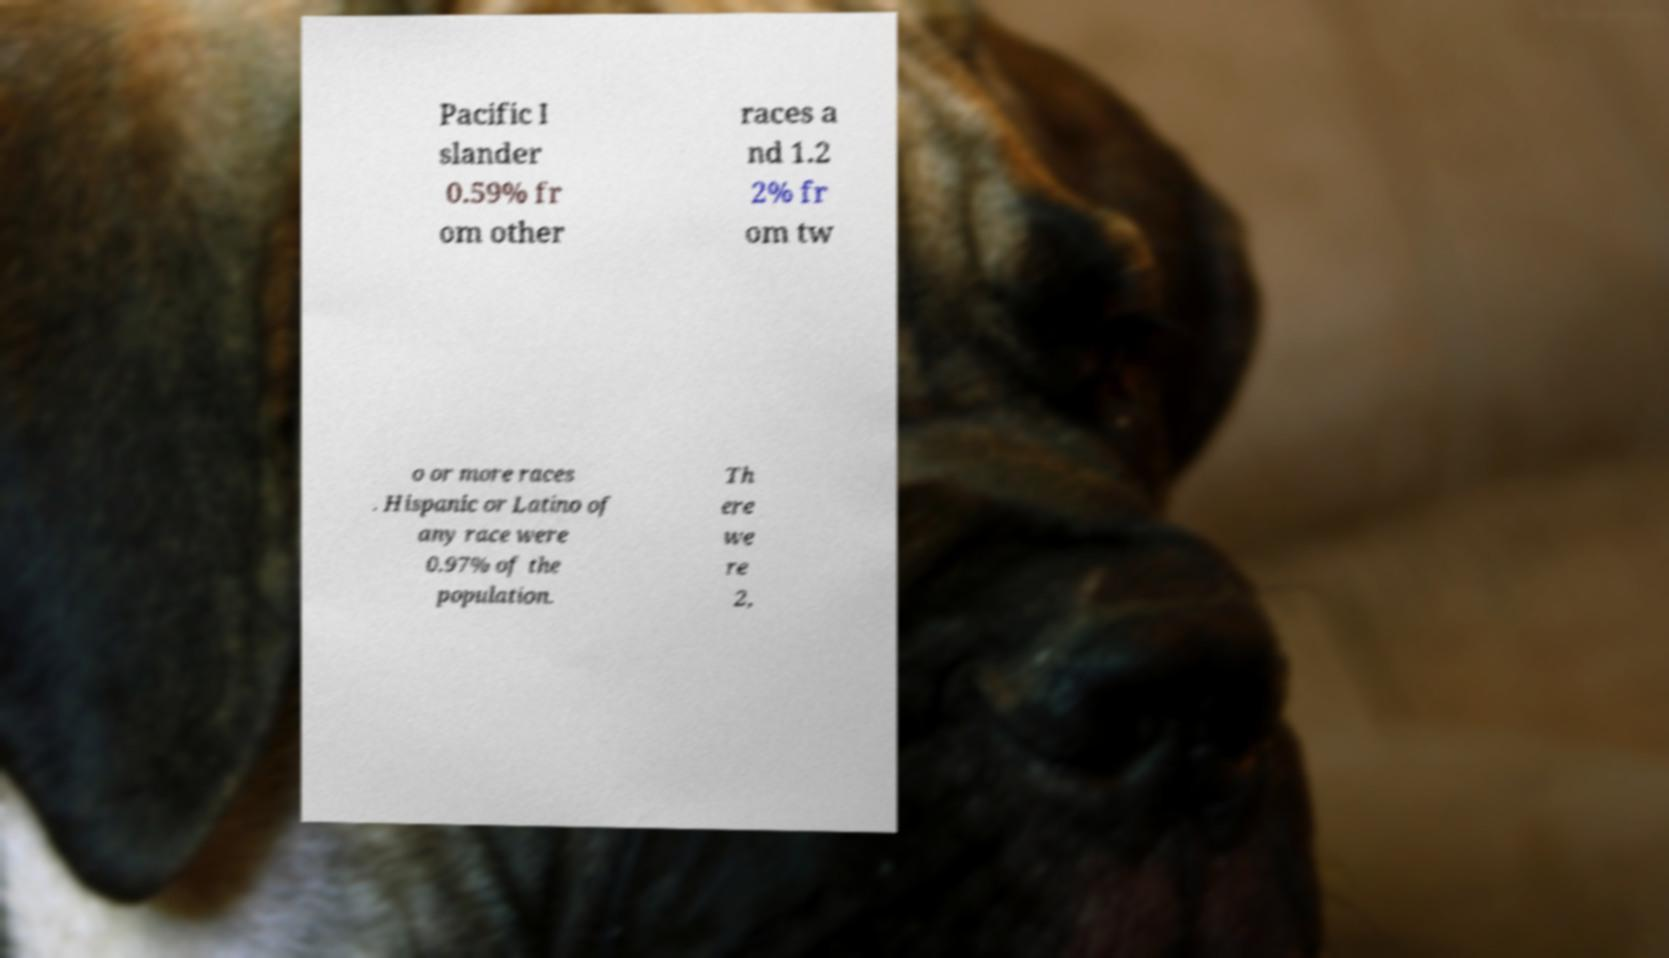Can you read and provide the text displayed in the image?This photo seems to have some interesting text. Can you extract and type it out for me? Pacific I slander 0.59% fr om other races a nd 1.2 2% fr om tw o or more races . Hispanic or Latino of any race were 0.97% of the population. Th ere we re 2, 